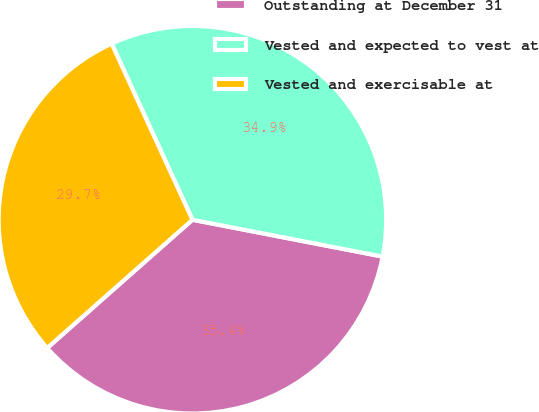Convert chart to OTSL. <chart><loc_0><loc_0><loc_500><loc_500><pie_chart><fcel>Outstanding at December 31<fcel>Vested and expected to vest at<fcel>Vested and exercisable at<nl><fcel>35.44%<fcel>34.89%<fcel>29.67%<nl></chart> 